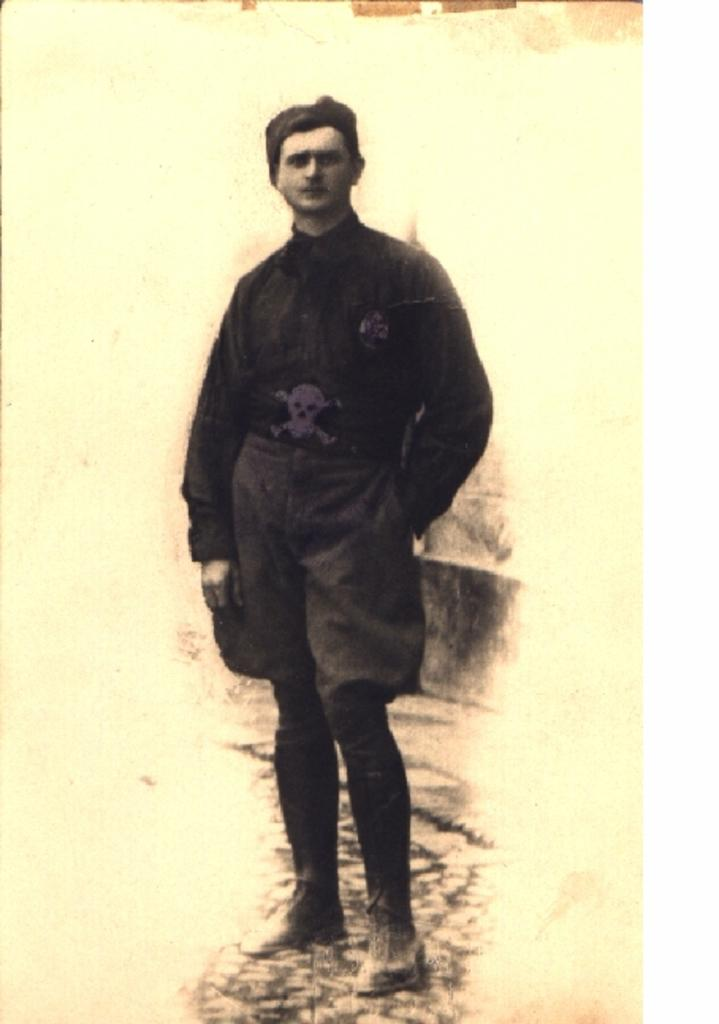What is the main subject of the image? There is a painting in the image. What type of celery can be seen growing in the yard depicted in the painting? There is no yard or celery present in the image, as it only features a painting. 